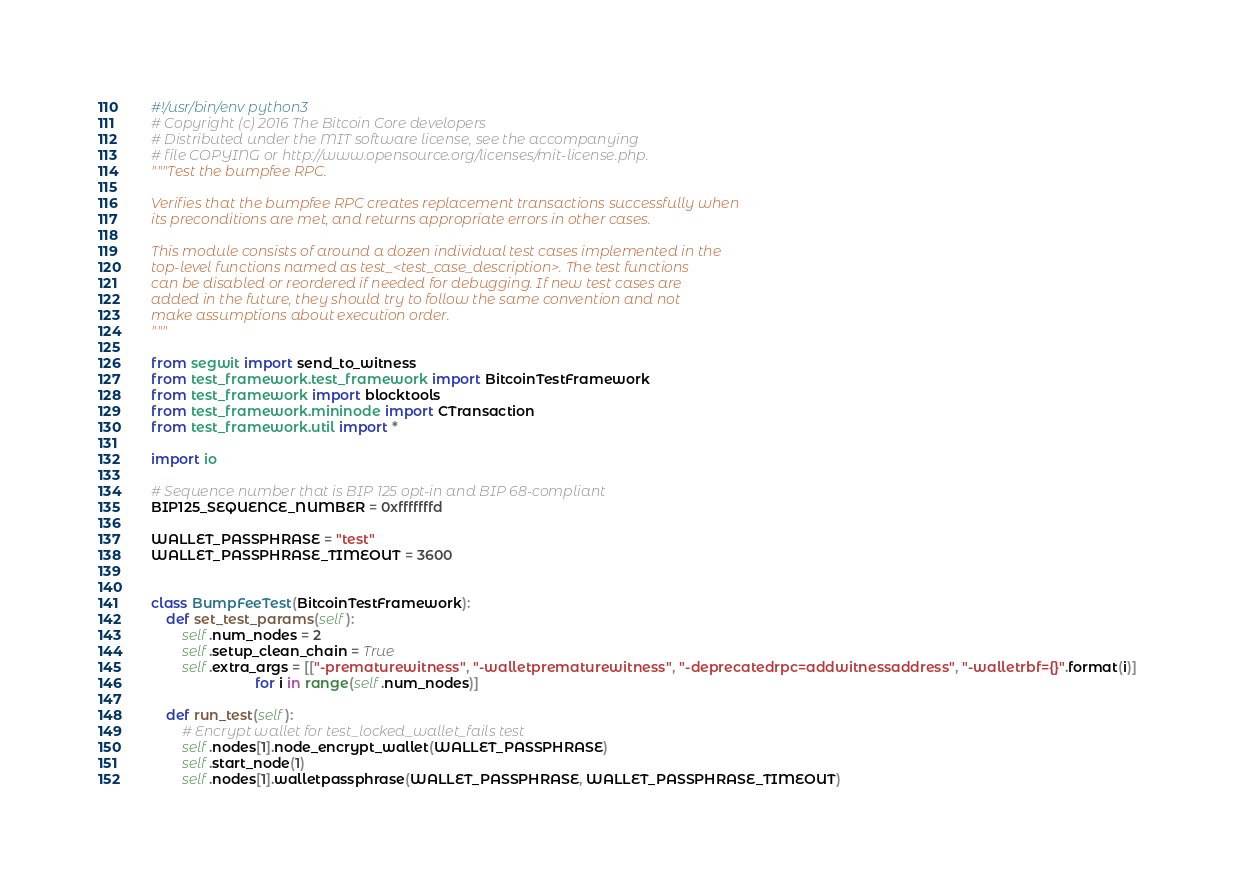<code> <loc_0><loc_0><loc_500><loc_500><_Python_>#!/usr/bin/env python3
# Copyright (c) 2016 The Bitcoin Core developers
# Distributed under the MIT software license, see the accompanying
# file COPYING or http://www.opensource.org/licenses/mit-license.php.
"""Test the bumpfee RPC.

Verifies that the bumpfee RPC creates replacement transactions successfully when
its preconditions are met, and returns appropriate errors in other cases.

This module consists of around a dozen individual test cases implemented in the
top-level functions named as test_<test_case_description>. The test functions
can be disabled or reordered if needed for debugging. If new test cases are
added in the future, they should try to follow the same convention and not
make assumptions about execution order.
"""

from segwit import send_to_witness
from test_framework.test_framework import BitcoinTestFramework
from test_framework import blocktools
from test_framework.mininode import CTransaction
from test_framework.util import *

import io

# Sequence number that is BIP 125 opt-in and BIP 68-compliant
BIP125_SEQUENCE_NUMBER = 0xfffffffd

WALLET_PASSPHRASE = "test"
WALLET_PASSPHRASE_TIMEOUT = 3600


class BumpFeeTest(BitcoinTestFramework):
    def set_test_params(self):
        self.num_nodes = 2
        self.setup_clean_chain = True
        self.extra_args = [["-prematurewitness", "-walletprematurewitness", "-deprecatedrpc=addwitnessaddress", "-walletrbf={}".format(i)]
                           for i in range(self.num_nodes)]

    def run_test(self):
        # Encrypt wallet for test_locked_wallet_fails test
        self.nodes[1].node_encrypt_wallet(WALLET_PASSPHRASE)
        self.start_node(1)
        self.nodes[1].walletpassphrase(WALLET_PASSPHRASE, WALLET_PASSPHRASE_TIMEOUT)
</code> 